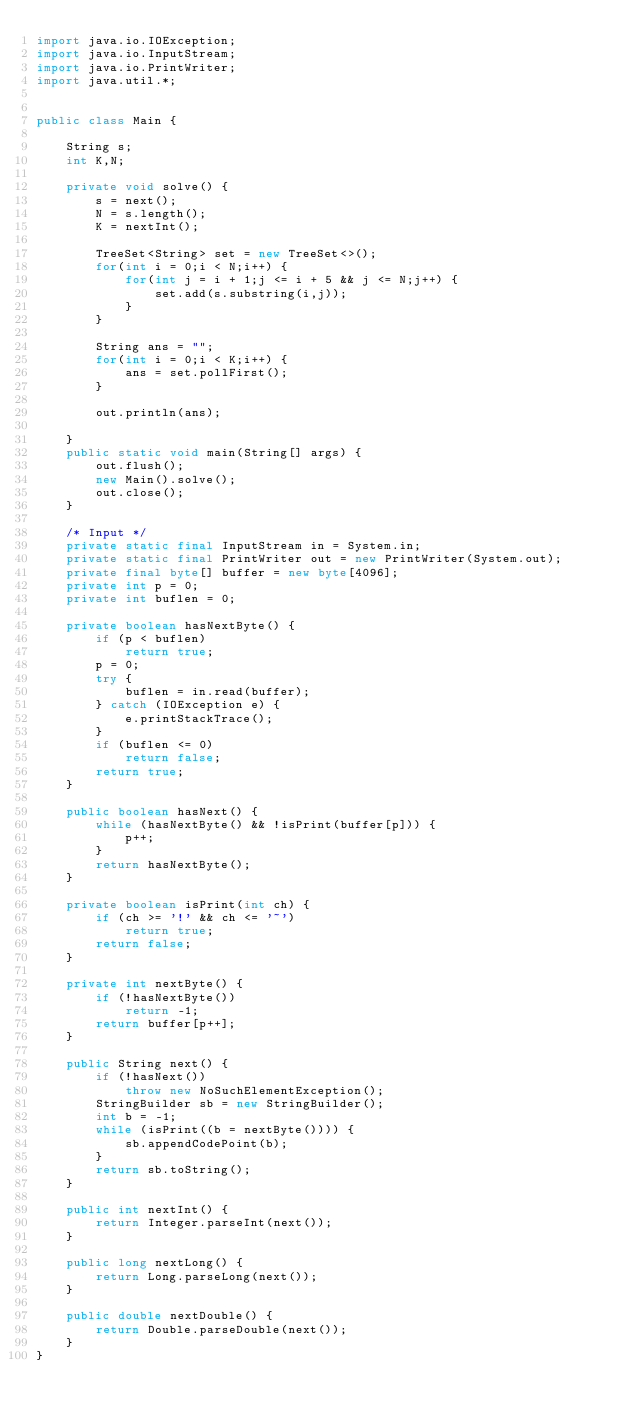Convert code to text. <code><loc_0><loc_0><loc_500><loc_500><_Java_>import java.io.IOException;
import java.io.InputStream;
import java.io.PrintWriter;
import java.util.*;


public class Main {

    String s;
    int K,N;

    private void solve() {
        s = next();
        N = s.length();
        K = nextInt();

        TreeSet<String> set = new TreeSet<>();
        for(int i = 0;i < N;i++) {
            for(int j = i + 1;j <= i + 5 && j <= N;j++) {
                set.add(s.substring(i,j));
            }
        }

        String ans = "";
        for(int i = 0;i < K;i++) {
            ans = set.pollFirst();
        }

        out.println(ans);

    }
    public static void main(String[] args) {
        out.flush();
        new Main().solve();
        out.close();
    }

    /* Input */
    private static final InputStream in = System.in;
    private static final PrintWriter out = new PrintWriter(System.out);
    private final byte[] buffer = new byte[4096];
    private int p = 0;
    private int buflen = 0;

    private boolean hasNextByte() {
        if (p < buflen)
            return true;
        p = 0;
        try {
            buflen = in.read(buffer);
        } catch (IOException e) {
            e.printStackTrace();
        }
        if (buflen <= 0)
            return false;
        return true;
    }

    public boolean hasNext() {
        while (hasNextByte() && !isPrint(buffer[p])) {
            p++;
        }
        return hasNextByte();
    }

    private boolean isPrint(int ch) {
        if (ch >= '!' && ch <= '~')
            return true;
        return false;
    }

    private int nextByte() {
        if (!hasNextByte())
            return -1;
        return buffer[p++];
    }

    public String next() {
        if (!hasNext())
            throw new NoSuchElementException();
        StringBuilder sb = new StringBuilder();
        int b = -1;
        while (isPrint((b = nextByte()))) {
            sb.appendCodePoint(b);
        }
        return sb.toString();
    }

    public int nextInt() {
        return Integer.parseInt(next());
    }

    public long nextLong() {
        return Long.parseLong(next());
    }

    public double nextDouble() {
        return Double.parseDouble(next());
    }
}
</code> 